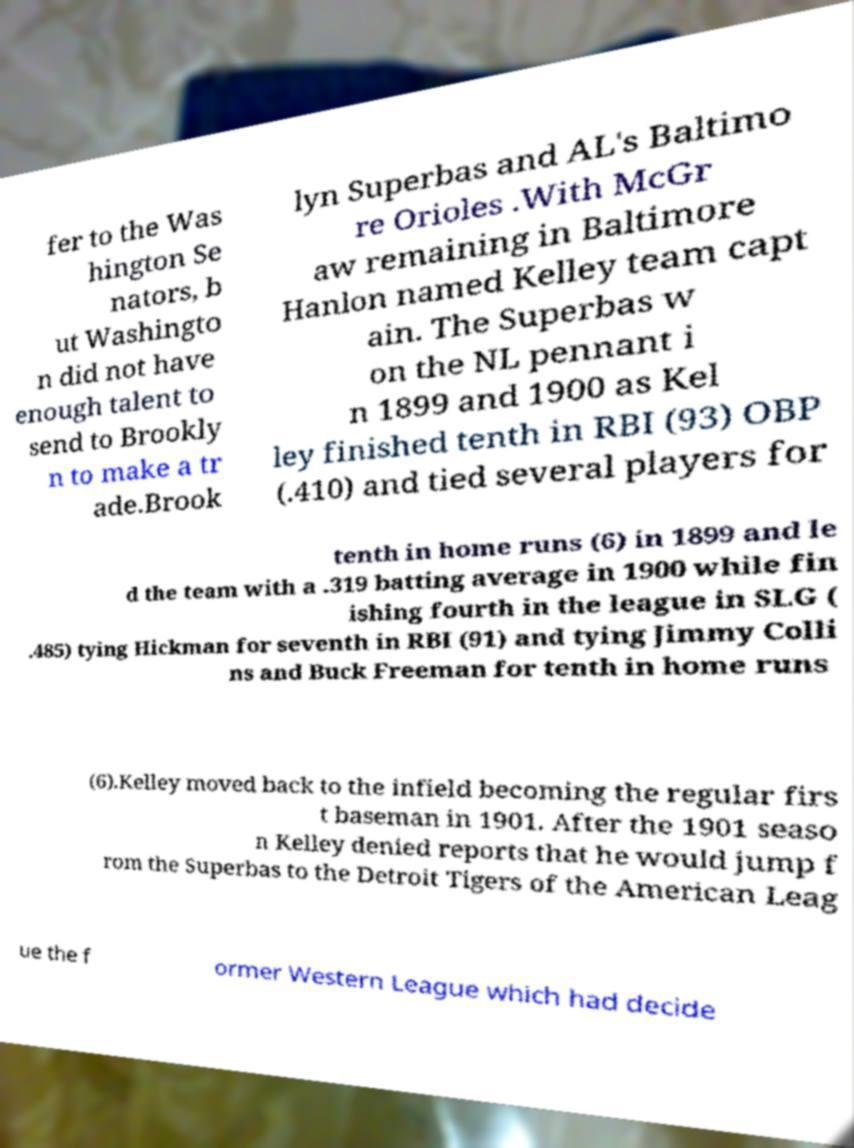Could you extract and type out the text from this image? fer to the Was hington Se nators, b ut Washingto n did not have enough talent to send to Brookly n to make a tr ade.Brook lyn Superbas and AL's Baltimo re Orioles .With McGr aw remaining in Baltimore Hanlon named Kelley team capt ain. The Superbas w on the NL pennant i n 1899 and 1900 as Kel ley finished tenth in RBI (93) OBP (.410) and tied several players for tenth in home runs (6) in 1899 and le d the team with a .319 batting average in 1900 while fin ishing fourth in the league in SLG ( .485) tying Hickman for seventh in RBI (91) and tying Jimmy Colli ns and Buck Freeman for tenth in home runs (6).Kelley moved back to the infield becoming the regular firs t baseman in 1901. After the 1901 seaso n Kelley denied reports that he would jump f rom the Superbas to the Detroit Tigers of the American Leag ue the f ormer Western League which had decide 